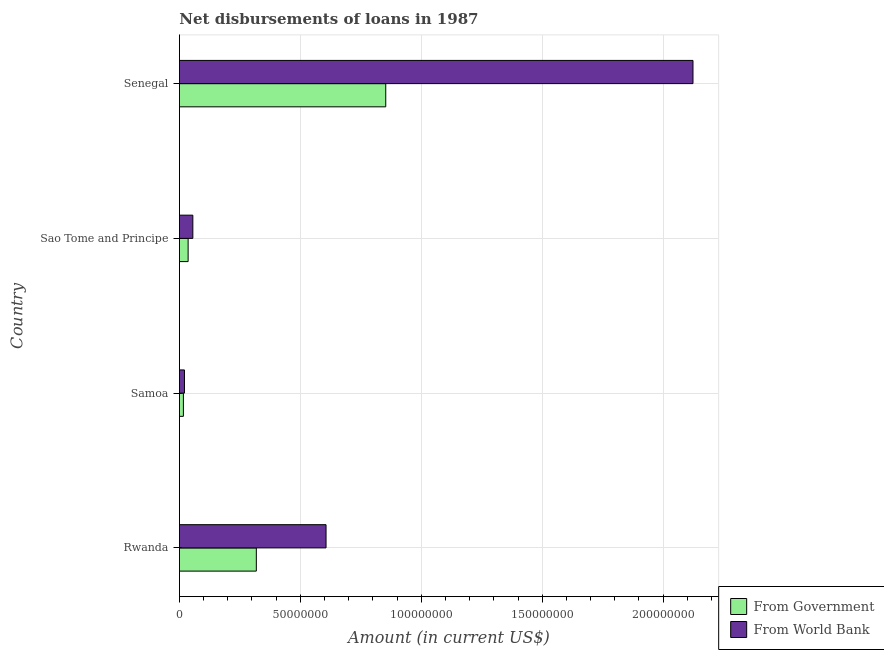Are the number of bars per tick equal to the number of legend labels?
Your response must be concise. Yes. Are the number of bars on each tick of the Y-axis equal?
Provide a succinct answer. Yes. How many bars are there on the 1st tick from the top?
Give a very brief answer. 2. How many bars are there on the 1st tick from the bottom?
Provide a succinct answer. 2. What is the label of the 3rd group of bars from the top?
Provide a succinct answer. Samoa. What is the net disbursements of loan from world bank in Sao Tome and Principe?
Your answer should be compact. 5.55e+06. Across all countries, what is the maximum net disbursements of loan from world bank?
Your answer should be compact. 2.12e+08. Across all countries, what is the minimum net disbursements of loan from government?
Your answer should be compact. 1.65e+06. In which country was the net disbursements of loan from government maximum?
Offer a very short reply. Senegal. In which country was the net disbursements of loan from government minimum?
Provide a short and direct response. Samoa. What is the total net disbursements of loan from government in the graph?
Your answer should be compact. 1.22e+08. What is the difference between the net disbursements of loan from government in Samoa and that in Sao Tome and Principe?
Keep it short and to the point. -1.95e+06. What is the difference between the net disbursements of loan from government in Samoa and the net disbursements of loan from world bank in Rwanda?
Ensure brevity in your answer.  -5.90e+07. What is the average net disbursements of loan from government per country?
Your answer should be compact. 3.06e+07. What is the difference between the net disbursements of loan from government and net disbursements of loan from world bank in Sao Tome and Principe?
Offer a terse response. -1.96e+06. What is the ratio of the net disbursements of loan from world bank in Rwanda to that in Senegal?
Provide a succinct answer. 0.29. Is the difference between the net disbursements of loan from world bank in Samoa and Sao Tome and Principe greater than the difference between the net disbursements of loan from government in Samoa and Sao Tome and Principe?
Provide a short and direct response. No. What is the difference between the highest and the second highest net disbursements of loan from government?
Your answer should be very brief. 5.35e+07. What is the difference between the highest and the lowest net disbursements of loan from world bank?
Give a very brief answer. 2.10e+08. In how many countries, is the net disbursements of loan from government greater than the average net disbursements of loan from government taken over all countries?
Your answer should be very brief. 2. Is the sum of the net disbursements of loan from world bank in Samoa and Senegal greater than the maximum net disbursements of loan from government across all countries?
Give a very brief answer. Yes. What does the 1st bar from the top in Rwanda represents?
Your response must be concise. From World Bank. What does the 1st bar from the bottom in Sao Tome and Principe represents?
Your response must be concise. From Government. How many bars are there?
Your response must be concise. 8. Are all the bars in the graph horizontal?
Ensure brevity in your answer.  Yes. What is the difference between two consecutive major ticks on the X-axis?
Keep it short and to the point. 5.00e+07. Where does the legend appear in the graph?
Your answer should be very brief. Bottom right. How many legend labels are there?
Make the answer very short. 2. What is the title of the graph?
Keep it short and to the point. Net disbursements of loans in 1987. What is the label or title of the X-axis?
Ensure brevity in your answer.  Amount (in current US$). What is the label or title of the Y-axis?
Provide a succinct answer. Country. What is the Amount (in current US$) in From Government in Rwanda?
Keep it short and to the point. 3.18e+07. What is the Amount (in current US$) of From World Bank in Rwanda?
Offer a very short reply. 6.06e+07. What is the Amount (in current US$) of From Government in Samoa?
Your response must be concise. 1.65e+06. What is the Amount (in current US$) in From World Bank in Samoa?
Offer a terse response. 2.09e+06. What is the Amount (in current US$) of From Government in Sao Tome and Principe?
Give a very brief answer. 3.60e+06. What is the Amount (in current US$) in From World Bank in Sao Tome and Principe?
Ensure brevity in your answer.  5.55e+06. What is the Amount (in current US$) in From Government in Senegal?
Your response must be concise. 8.53e+07. What is the Amount (in current US$) in From World Bank in Senegal?
Make the answer very short. 2.12e+08. Across all countries, what is the maximum Amount (in current US$) of From Government?
Offer a very short reply. 8.53e+07. Across all countries, what is the maximum Amount (in current US$) in From World Bank?
Offer a very short reply. 2.12e+08. Across all countries, what is the minimum Amount (in current US$) of From Government?
Provide a short and direct response. 1.65e+06. Across all countries, what is the minimum Amount (in current US$) of From World Bank?
Give a very brief answer. 2.09e+06. What is the total Amount (in current US$) in From Government in the graph?
Offer a terse response. 1.22e+08. What is the total Amount (in current US$) in From World Bank in the graph?
Keep it short and to the point. 2.81e+08. What is the difference between the Amount (in current US$) of From Government in Rwanda and that in Samoa?
Keep it short and to the point. 3.02e+07. What is the difference between the Amount (in current US$) in From World Bank in Rwanda and that in Samoa?
Ensure brevity in your answer.  5.85e+07. What is the difference between the Amount (in current US$) in From Government in Rwanda and that in Sao Tome and Principe?
Provide a short and direct response. 2.82e+07. What is the difference between the Amount (in current US$) in From World Bank in Rwanda and that in Sao Tome and Principe?
Provide a succinct answer. 5.51e+07. What is the difference between the Amount (in current US$) in From Government in Rwanda and that in Senegal?
Provide a short and direct response. -5.35e+07. What is the difference between the Amount (in current US$) in From World Bank in Rwanda and that in Senegal?
Offer a very short reply. -1.52e+08. What is the difference between the Amount (in current US$) of From Government in Samoa and that in Sao Tome and Principe?
Make the answer very short. -1.95e+06. What is the difference between the Amount (in current US$) of From World Bank in Samoa and that in Sao Tome and Principe?
Offer a terse response. -3.47e+06. What is the difference between the Amount (in current US$) of From Government in Samoa and that in Senegal?
Your answer should be very brief. -8.37e+07. What is the difference between the Amount (in current US$) of From World Bank in Samoa and that in Senegal?
Your answer should be compact. -2.10e+08. What is the difference between the Amount (in current US$) in From Government in Sao Tome and Principe and that in Senegal?
Your answer should be very brief. -8.17e+07. What is the difference between the Amount (in current US$) in From World Bank in Sao Tome and Principe and that in Senegal?
Offer a very short reply. -2.07e+08. What is the difference between the Amount (in current US$) in From Government in Rwanda and the Amount (in current US$) in From World Bank in Samoa?
Make the answer very short. 2.97e+07. What is the difference between the Amount (in current US$) in From Government in Rwanda and the Amount (in current US$) in From World Bank in Sao Tome and Principe?
Offer a terse response. 2.62e+07. What is the difference between the Amount (in current US$) in From Government in Rwanda and the Amount (in current US$) in From World Bank in Senegal?
Give a very brief answer. -1.81e+08. What is the difference between the Amount (in current US$) of From Government in Samoa and the Amount (in current US$) of From World Bank in Sao Tome and Principe?
Make the answer very short. -3.91e+06. What is the difference between the Amount (in current US$) of From Government in Samoa and the Amount (in current US$) of From World Bank in Senegal?
Give a very brief answer. -2.11e+08. What is the difference between the Amount (in current US$) in From Government in Sao Tome and Principe and the Amount (in current US$) in From World Bank in Senegal?
Your answer should be compact. -2.09e+08. What is the average Amount (in current US$) of From Government per country?
Provide a short and direct response. 3.06e+07. What is the average Amount (in current US$) of From World Bank per country?
Offer a terse response. 7.01e+07. What is the difference between the Amount (in current US$) in From Government and Amount (in current US$) in From World Bank in Rwanda?
Your response must be concise. -2.88e+07. What is the difference between the Amount (in current US$) in From Government and Amount (in current US$) in From World Bank in Samoa?
Your answer should be compact. -4.41e+05. What is the difference between the Amount (in current US$) in From Government and Amount (in current US$) in From World Bank in Sao Tome and Principe?
Keep it short and to the point. -1.96e+06. What is the difference between the Amount (in current US$) of From Government and Amount (in current US$) of From World Bank in Senegal?
Keep it short and to the point. -1.27e+08. What is the ratio of the Amount (in current US$) in From Government in Rwanda to that in Samoa?
Provide a short and direct response. 19.31. What is the ratio of the Amount (in current US$) of From World Bank in Rwanda to that in Samoa?
Your response must be concise. 29.03. What is the ratio of the Amount (in current US$) of From Government in Rwanda to that in Sao Tome and Principe?
Your answer should be very brief. 8.84. What is the ratio of the Amount (in current US$) of From World Bank in Rwanda to that in Sao Tome and Principe?
Make the answer very short. 10.91. What is the ratio of the Amount (in current US$) of From Government in Rwanda to that in Senegal?
Ensure brevity in your answer.  0.37. What is the ratio of the Amount (in current US$) in From World Bank in Rwanda to that in Senegal?
Offer a terse response. 0.29. What is the ratio of the Amount (in current US$) of From Government in Samoa to that in Sao Tome and Principe?
Provide a succinct answer. 0.46. What is the ratio of the Amount (in current US$) of From World Bank in Samoa to that in Sao Tome and Principe?
Your answer should be compact. 0.38. What is the ratio of the Amount (in current US$) of From Government in Samoa to that in Senegal?
Your answer should be very brief. 0.02. What is the ratio of the Amount (in current US$) of From World Bank in Samoa to that in Senegal?
Provide a succinct answer. 0.01. What is the ratio of the Amount (in current US$) in From Government in Sao Tome and Principe to that in Senegal?
Provide a short and direct response. 0.04. What is the ratio of the Amount (in current US$) in From World Bank in Sao Tome and Principe to that in Senegal?
Provide a short and direct response. 0.03. What is the difference between the highest and the second highest Amount (in current US$) of From Government?
Your response must be concise. 5.35e+07. What is the difference between the highest and the second highest Amount (in current US$) in From World Bank?
Your answer should be very brief. 1.52e+08. What is the difference between the highest and the lowest Amount (in current US$) of From Government?
Give a very brief answer. 8.37e+07. What is the difference between the highest and the lowest Amount (in current US$) in From World Bank?
Provide a short and direct response. 2.10e+08. 